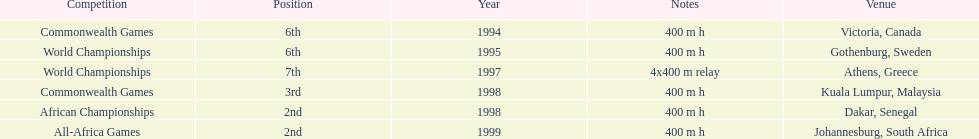What is the name of the last competition? All-Africa Games. 